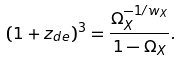<formula> <loc_0><loc_0><loc_500><loc_500>( 1 + z _ { d e } ) ^ { 3 } = \frac { \Omega _ { X } ^ { - 1 / w _ { X } } } { 1 - \Omega _ { X } } .</formula> 